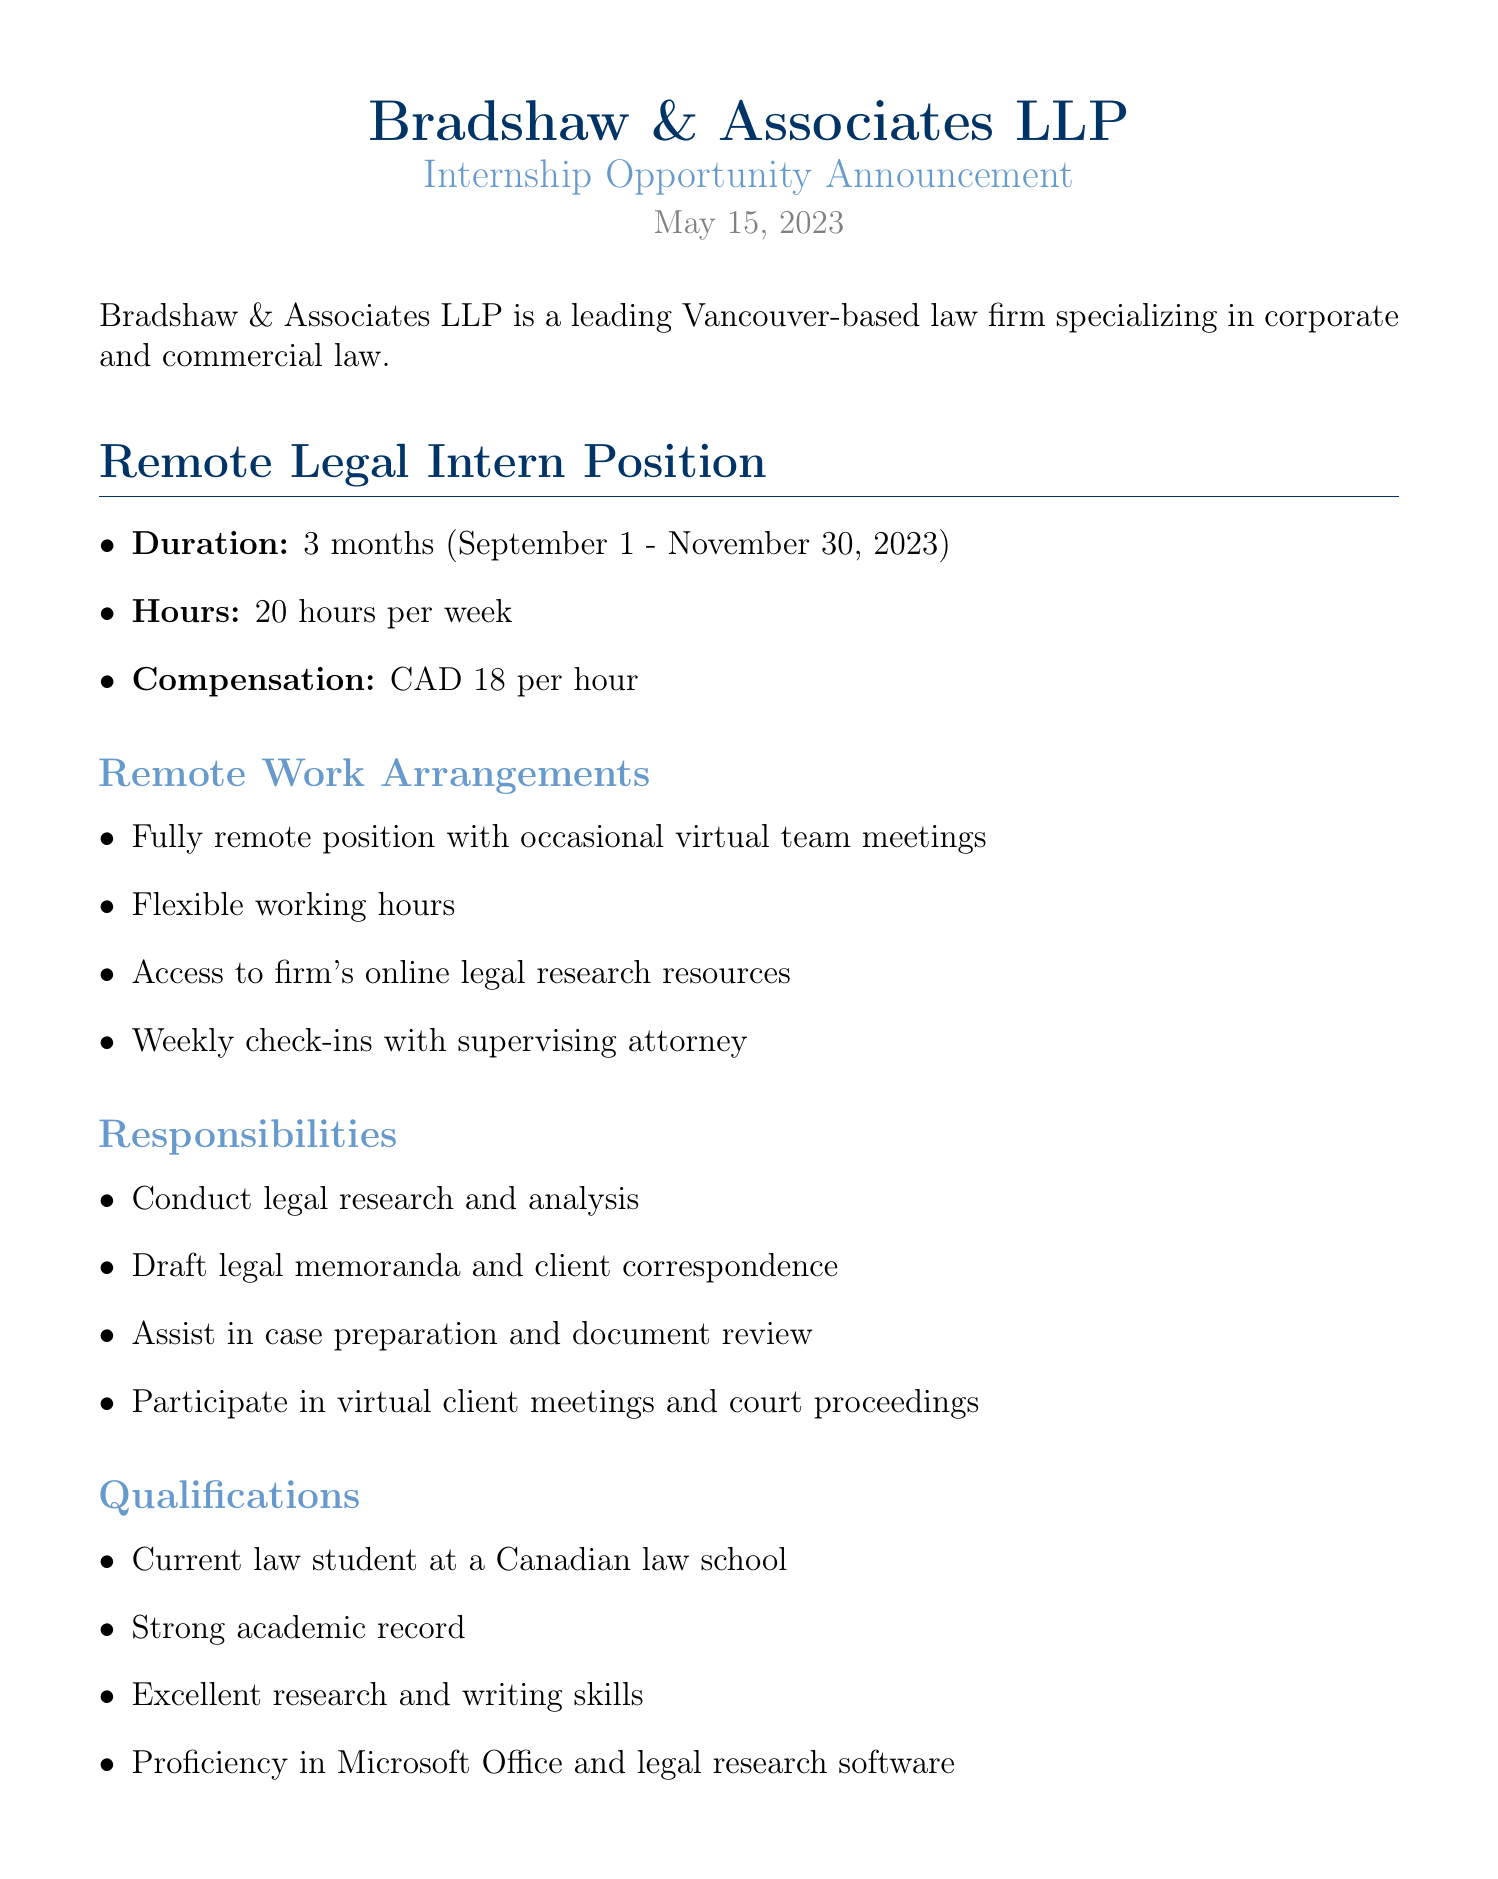what is the duration of the internship? The duration is specified in the document as September 1 to November 30, 2023, which is a span of 3 months.
Answer: 3 months what is the hourly compensation for the position? The document states that the compensation is CAD 18 per hour for the intern position.
Answer: CAD 18 per hour who should the application be sent to? The document specifies the email address for submissions as internships@bradshawassociates.ca.
Answer: internships@bradshawassociates.ca how many hours per week is the internship? It is stated in the document that the intern is expected to work 20 hours per week.
Answer: 20 hours per week what is one of the qualifications needed for the position? The document lists various qualifications, one being that the applicant must be a current law student at a Canadian law school.
Answer: Current law student at a Canadian law school what is the deadline for submitting applications? The deadline for applications is mentioned as June 30, 2023, in the document.
Answer: June 30, 2023 what type of position is being offered? The document specifies that it is a Remote Legal Intern Position.
Answer: Remote Legal Intern Position how often will the intern have check-ins with the supervising attorney? The document mentions that there will be weekly check-ins with the supervising attorney.
Answer: Weekly what documents are required to apply? The required documents include a cover letter, resume, unofficial transcript, and a writing sample.
Answer: Cover letter, Resume, Unofficial transcript, Writing sample 